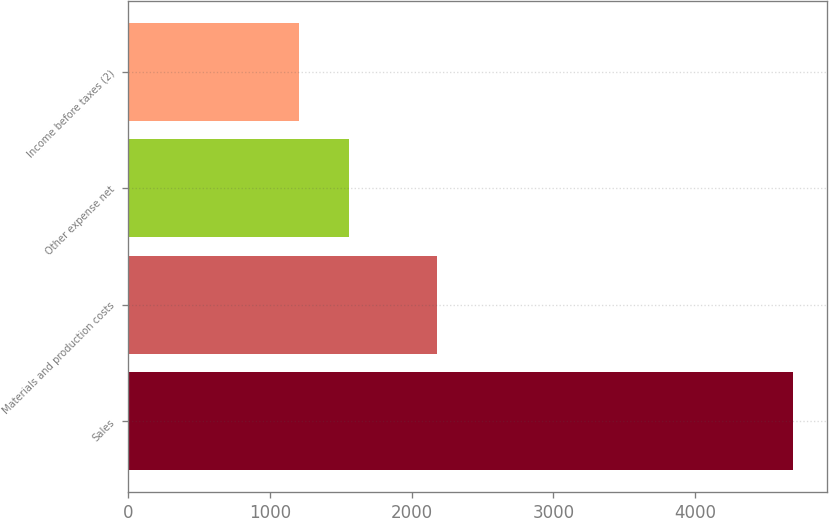<chart> <loc_0><loc_0><loc_500><loc_500><bar_chart><fcel>Sales<fcel>Materials and production costs<fcel>Other expense net<fcel>Income before taxes (2)<nl><fcel>4694<fcel>2177<fcel>1553.9<fcel>1205<nl></chart> 